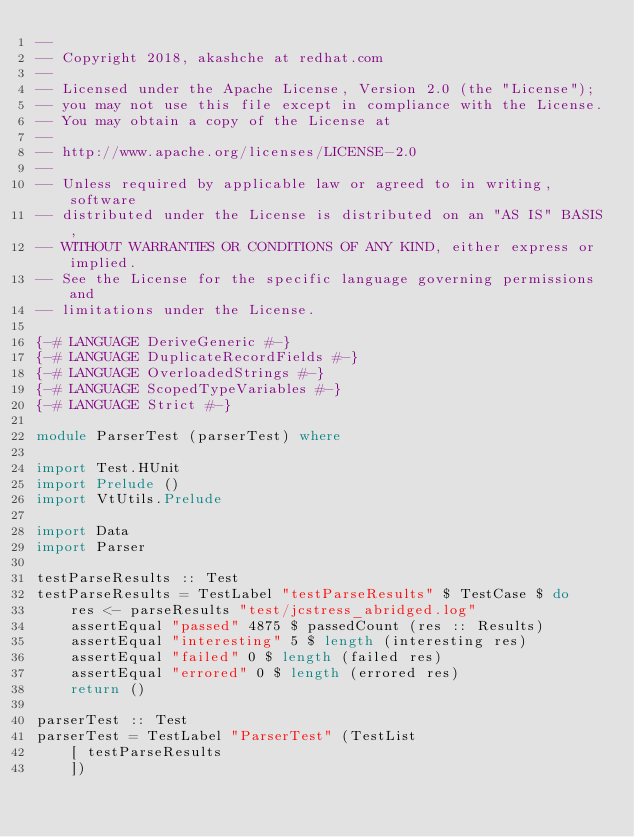<code> <loc_0><loc_0><loc_500><loc_500><_Haskell_>--
-- Copyright 2018, akashche at redhat.com
--
-- Licensed under the Apache License, Version 2.0 (the "License");
-- you may not use this file except in compliance with the License.
-- You may obtain a copy of the License at
--
-- http://www.apache.org/licenses/LICENSE-2.0
--
-- Unless required by applicable law or agreed to in writing, software
-- distributed under the License is distributed on an "AS IS" BASIS,
-- WITHOUT WARRANTIES OR CONDITIONS OF ANY KIND, either express or implied.
-- See the License for the specific language governing permissions and
-- limitations under the License.

{-# LANGUAGE DeriveGeneric #-}
{-# LANGUAGE DuplicateRecordFields #-}
{-# LANGUAGE OverloadedStrings #-}
{-# LANGUAGE ScopedTypeVariables #-}
{-# LANGUAGE Strict #-}

module ParserTest (parserTest) where

import Test.HUnit
import Prelude ()
import VtUtils.Prelude

import Data
import Parser

testParseResults :: Test
testParseResults = TestLabel "testParseResults" $ TestCase $ do
    res <- parseResults "test/jcstress_abridged.log"
    assertEqual "passed" 4875 $ passedCount (res :: Results)
    assertEqual "interesting" 5 $ length (interesting res)
    assertEqual "failed" 0 $ length (failed res)
    assertEqual "errored" 0 $ length (errored res)
    return ()

parserTest :: Test
parserTest = TestLabel "ParserTest" (TestList
    [ testParseResults
    ])
</code> 